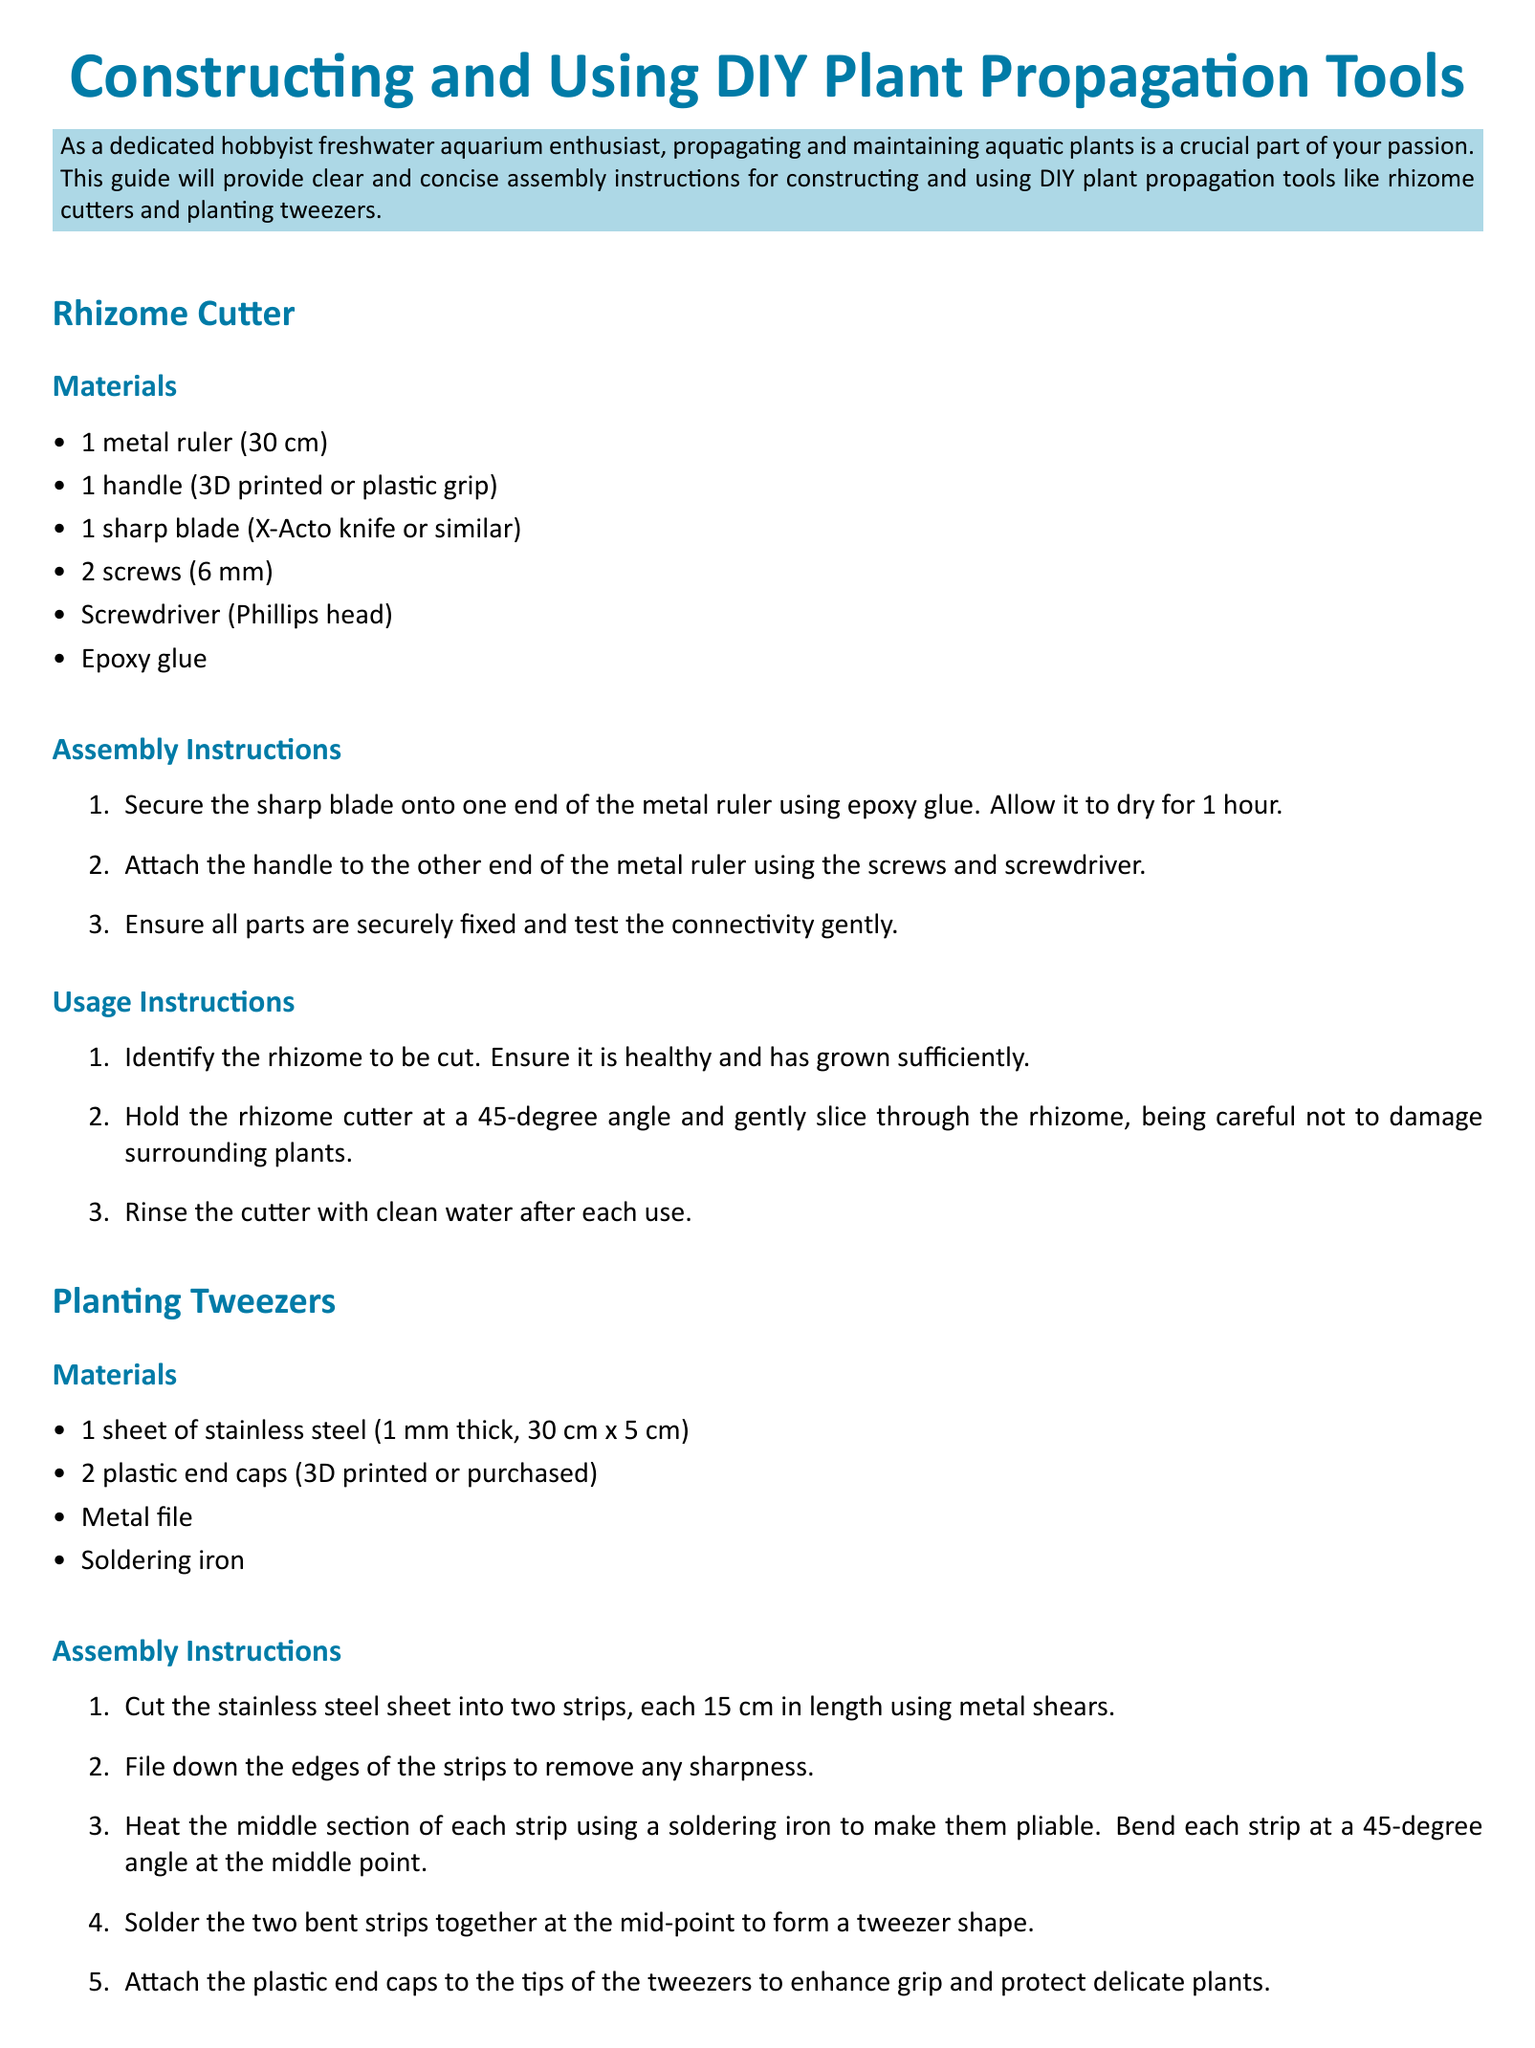What materials are needed for the rhizome cutter? The materials for the rhizome cutter are listed in the document, including a metal ruler, handle, sharp blade, screws, screwdriver, and epoxy glue.
Answer: metal ruler, handle, sharp blade, screws, screwdriver, epoxy glue How long should the stainless steel sheet be for the planting tweezers? The document states the dimensions of the stainless steel sheet used for the planting tweezers.
Answer: 30 cm What shape should the strips be bent into when making the planting tweezers? The assembly instructions detail that each strip should be bent at a 45-degree angle.
Answer: 45-degree angle What is the first step in the assembly instructions for the rhizome cutter? The document specifies that the first step is to secure the sharp blade onto the metal ruler using epoxy glue.
Answer: secure the sharp blade onto the metal ruler What should be done after each use of the rhizome cutter? The usage instructions suggest rinsing the cutter with clean water after each use.
Answer: rinse the cutter with clean water How many strips are made from the stainless steel sheet for the tweezers? The assembly instructions outline that the stainless steel sheet is cut into two strips.
Answer: two strips What type of tool is recommended to use when handling sharp items? The document notes that protective gloves should be worn when handling sharp tools.
Answer: protective gloves What material enhances the grip of the planting tweezers? The assembly instructions mention attaching plastic end caps to the tips of the tweezers to enhance grip.
Answer: plastic end caps 